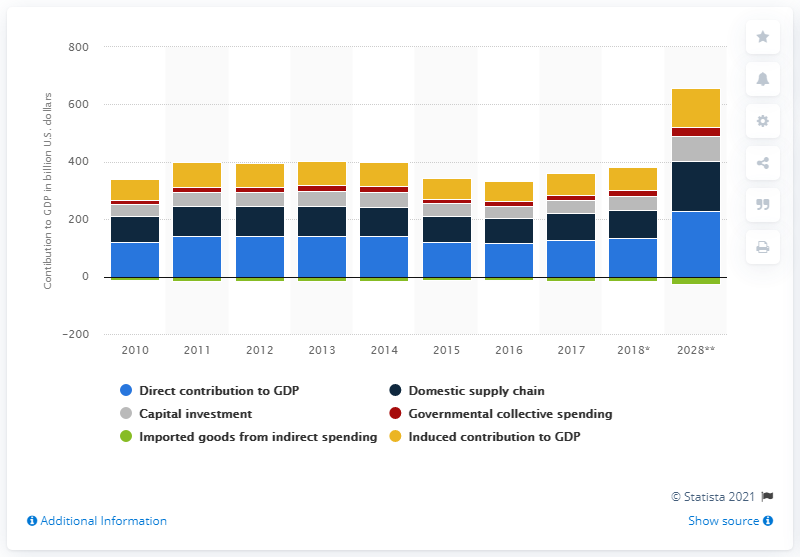Specify some key components in this picture. According to the forecast, the induced contribution of travel and tourism to the Latin American economy is expected to reach 136.2 by 2028. 